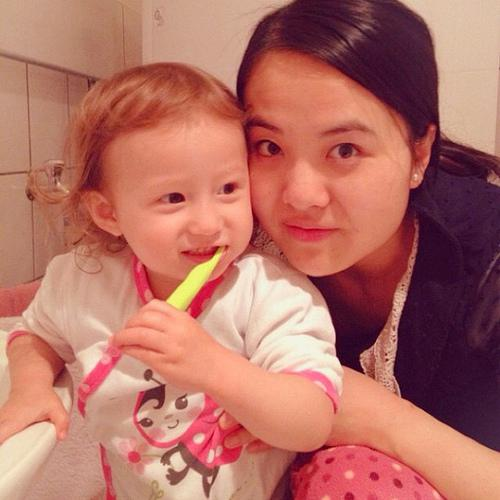Question: where was the picture taken?
Choices:
A. In a kitchen.
B. In a house.
C. In a bathroom.
D. In a  bedroom.
Answer with the letter. Answer: C Question: why is a child holding a toothbrush?
Choices:
A. The dentist gave it to her.
B. She is buying a new one.
C. To brush her teeth.
D. To pack it for vacation.
Answer with the letter. Answer: C Question: what is a little kid doing?
Choices:
A. Brushing teeth.
B. Washing their face.
C. Flossing.
D. Blowing their nose.
Answer with the letter. Answer: A Question: how many people are in the photo?
Choices:
A. One.
B. Two.
C. Six.
D. Seven.
Answer with the letter. Answer: B Question: who has black hair?
Choices:
A. The child.
B. The entire family.
C. The man over there.
D. Woman on right.
Answer with the letter. Answer: D Question: who has red hair?
Choices:
A. The kid.
B. The mother.
C. The father.
D. The whole family.
Answer with the letter. Answer: A Question: what is white?
Choices:
A. The child's socks.
B. The child's hat.
C. The child's shirt.
D. The child's shorts.
Answer with the letter. Answer: C 